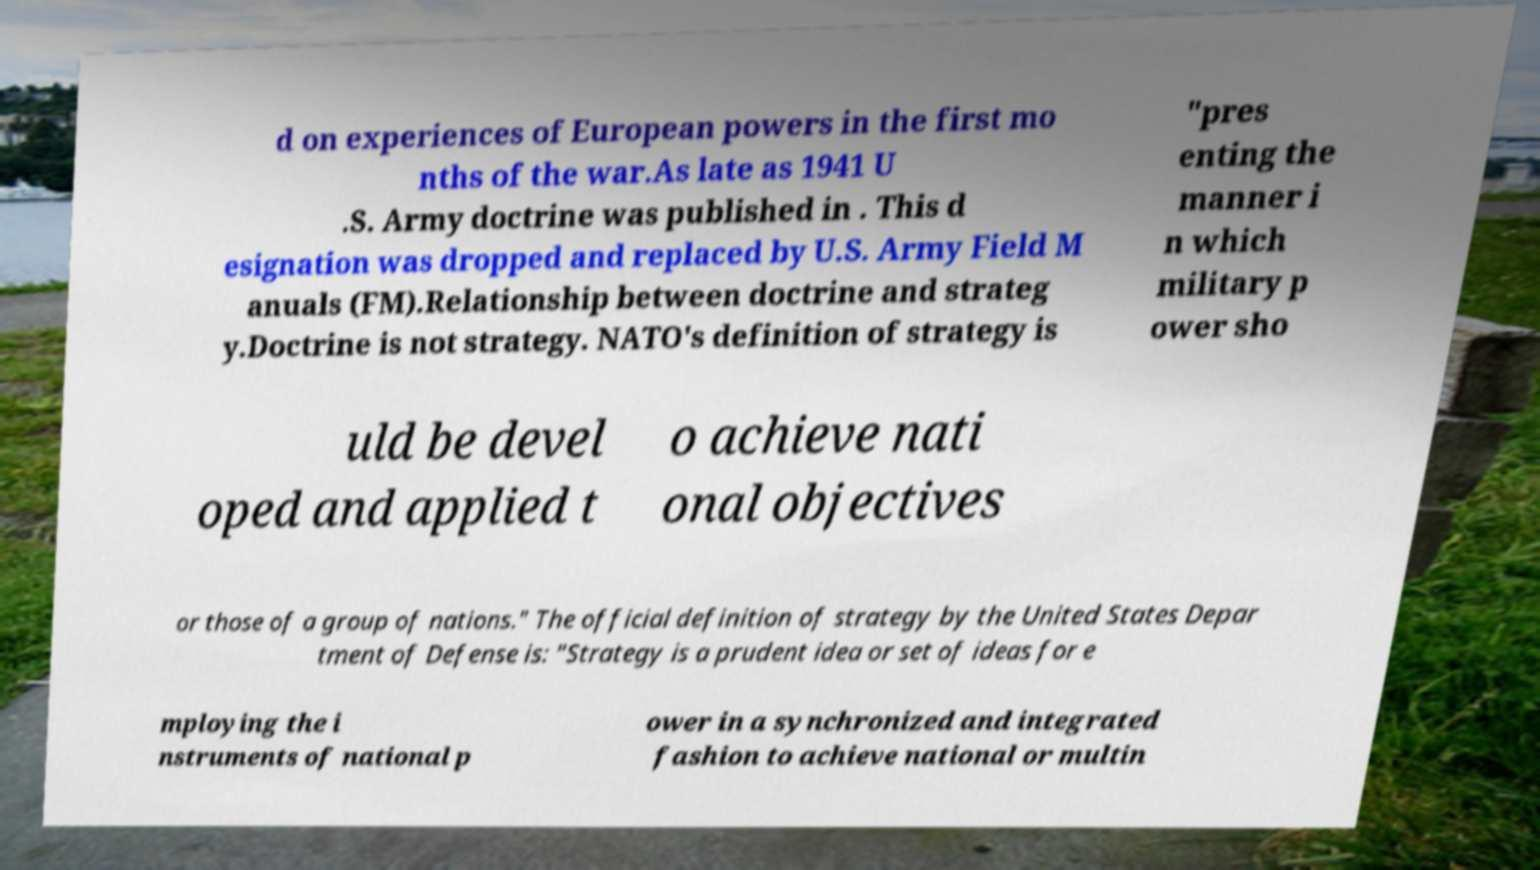I need the written content from this picture converted into text. Can you do that? d on experiences of European powers in the first mo nths of the war.As late as 1941 U .S. Army doctrine was published in . This d esignation was dropped and replaced by U.S. Army Field M anuals (FM).Relationship between doctrine and strateg y.Doctrine is not strategy. NATO's definition of strategy is "pres enting the manner i n which military p ower sho uld be devel oped and applied t o achieve nati onal objectives or those of a group of nations." The official definition of strategy by the United States Depar tment of Defense is: "Strategy is a prudent idea or set of ideas for e mploying the i nstruments of national p ower in a synchronized and integrated fashion to achieve national or multin 